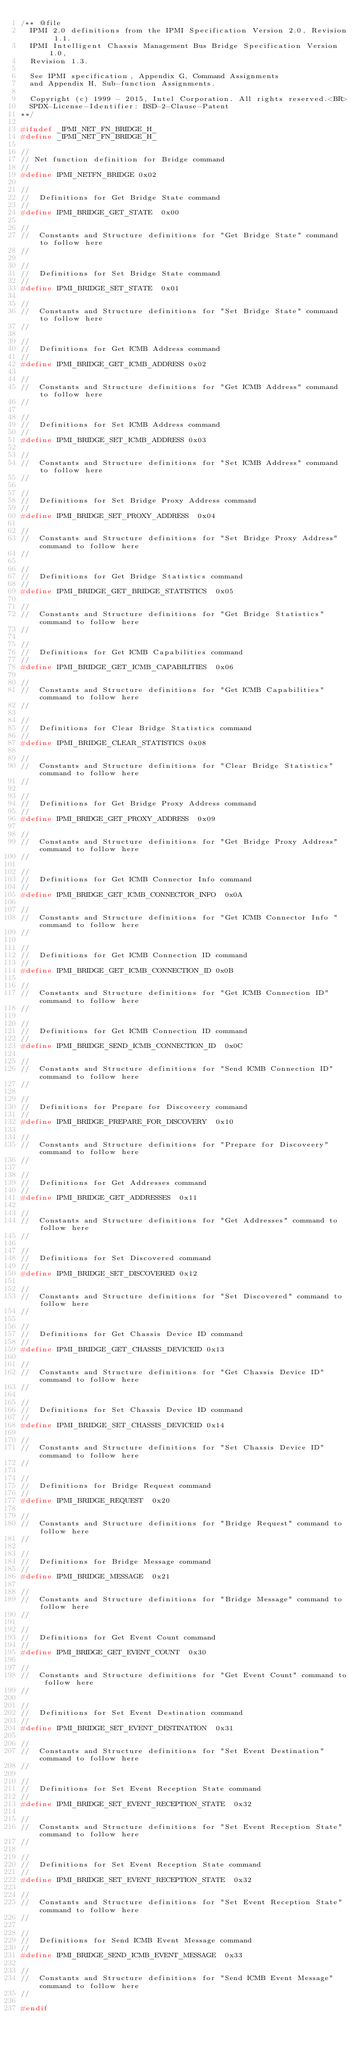Convert code to text. <code><loc_0><loc_0><loc_500><loc_500><_C_>/** @file
  IPMI 2.0 definitions from the IPMI Specification Version 2.0, Revision 1.1.
  IPMI Intelligent Chassis Management Bus Bridge Specification Version 1.0,
  Revision 1.3.

  See IPMI specification, Appendix G, Command Assignments
  and Appendix H, Sub-function Assignments.

  Copyright (c) 1999 - 2015, Intel Corporation. All rights reserved.<BR>
  SPDX-License-Identifier: BSD-2-Clause-Patent
**/

#ifndef _IPMI_NET_FN_BRIDGE_H_
#define _IPMI_NET_FN_BRIDGE_H_

//
// Net function definition for Bridge command
//
#define IPMI_NETFN_BRIDGE 0x02

//
//  Definitions for Get Bridge State command
//
#define IPMI_BRIDGE_GET_STATE  0x00

//
//  Constants and Structure definitions for "Get Bridge State" command to follow here
//

//
//  Definitions for Set Bridge State command
//
#define IPMI_BRIDGE_SET_STATE  0x01

//
//  Constants and Structure definitions for "Set Bridge State" command to follow here
//

//
//  Definitions for Get ICMB Address command
//
#define IPMI_BRIDGE_GET_ICMB_ADDRESS 0x02

//
//  Constants and Structure definitions for "Get ICMB Address" command to follow here
//

//
//  Definitions for Set ICMB Address command
//
#define IPMI_BRIDGE_SET_ICMB_ADDRESS 0x03

//
//  Constants and Structure definitions for "Set ICMB Address" command to follow here
//

//
//  Definitions for Set Bridge Proxy Address command
//
#define IPMI_BRIDGE_SET_PROXY_ADDRESS  0x04

//
//  Constants and Structure definitions for "Set Bridge Proxy Address" command to follow here
//

//
//  Definitions for Get Bridge Statistics command
//
#define IPMI_BRIDGE_GET_BRIDGE_STATISTICS  0x05

//
//  Constants and Structure definitions for "Get Bridge Statistics" command to follow here
//

//
//  Definitions for Get ICMB Capabilities command
//
#define IPMI_BRIDGE_GET_ICMB_CAPABILITIES  0x06

//
//  Constants and Structure definitions for "Get ICMB Capabilities" command to follow here
//

//
//  Definitions for Clear Bridge Statistics command
//
#define IPMI_BRIDGE_CLEAR_STATISTICS 0x08

//
//  Constants and Structure definitions for "Clear Bridge Statistics" command to follow here
//

//
//  Definitions for Get Bridge Proxy Address command
//
#define IPMI_BRIDGE_GET_PROXY_ADDRESS  0x09

//
//  Constants and Structure definitions for "Get Bridge Proxy Address" command to follow here
//

//
//  Definitions for Get ICMB Connector Info command
//
#define IPMI_BRIDGE_GET_ICMB_CONNECTOR_INFO  0x0A

//
//  Constants and Structure definitions for "Get ICMB Connector Info " command to follow here
//

//
//  Definitions for Get ICMB Connection ID command
//
#define IPMI_BRIDGE_GET_ICMB_CONNECTION_ID 0x0B

//
//  Constants and Structure definitions for "Get ICMB Connection ID" command to follow here
//

//
//  Definitions for Get ICMB Connection ID command
//
#define IPMI_BRIDGE_SEND_ICMB_CONNECTION_ID  0x0C

//
//  Constants and Structure definitions for "Send ICMB Connection ID" command to follow here
//

//
//  Definitions for Prepare for Discoveery command
//
#define IPMI_BRIDGE_PREPARE_FOR_DISCOVERY  0x10

//
//  Constants and Structure definitions for "Prepare for Discoveery" command to follow here
//

//
//  Definitions for Get Addresses command
//
#define IPMI_BRIDGE_GET_ADDRESSES  0x11

//
//  Constants and Structure definitions for "Get Addresses" command to follow here
//

//
//  Definitions for Set Discovered command
//
#define IPMI_BRIDGE_SET_DISCOVERED 0x12

//
//  Constants and Structure definitions for "Set Discovered" command to follow here
//

//
//  Definitions for Get Chassis Device ID command
//
#define IPMI_BRIDGE_GET_CHASSIS_DEVICEID 0x13

//
//  Constants and Structure definitions for "Get Chassis Device ID" command to follow here
//

//
//  Definitions for Set Chassis Device ID command
//
#define IPMI_BRIDGE_SET_CHASSIS_DEVICEID 0x14

//
//  Constants and Structure definitions for "Set Chassis Device ID" command to follow here
//

//
//  Definitions for Bridge Request command
//
#define IPMI_BRIDGE_REQUEST  0x20

//
//  Constants and Structure definitions for "Bridge Request" command to follow here
//

//
//  Definitions for Bridge Message command
//
#define IPMI_BRIDGE_MESSAGE  0x21

//
//  Constants and Structure definitions for "Bridge Message" command to follow here
//

//
//  Definitions for Get Event Count command
//
#define IPMI_BRIDGE_GET_EVENT_COUNT  0x30

//
//  Constants and Structure definitions for "Get Event Count" command to follow here
//

//
//  Definitions for Set Event Destination command
//
#define IPMI_BRIDGE_SET_EVENT_DESTINATION  0x31

//
//  Constants and Structure definitions for "Set Event Destination" command to follow here
//

//
//  Definitions for Set Event Reception State command
//
#define IPMI_BRIDGE_SET_EVENT_RECEPTION_STATE  0x32

//
//  Constants and Structure definitions for "Set Event Reception State" command to follow here
//

//
//  Definitions for Set Event Reception State command
//
#define IPMI_BRIDGE_SET_EVENT_RECEPTION_STATE  0x32

//
//  Constants and Structure definitions for "Set Event Reception State" command to follow here
//

//
//  Definitions for Send ICMB Event Message command
//
#define IPMI_BRIDGE_SEND_ICMB_EVENT_MESSAGE  0x33

//
//  Constants and Structure definitions for "Send ICMB Event Message" command to follow here
//

#endif
</code> 